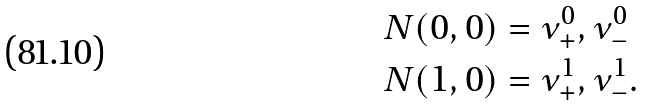<formula> <loc_0><loc_0><loc_500><loc_500>N ( 0 , 0 ) & = \nu ^ { 0 } _ { + } , \nu ^ { 0 } _ { - } \\ N ( 1 , 0 ) & = \nu ^ { 1 } _ { + } , \nu ^ { 1 } _ { - } .</formula> 